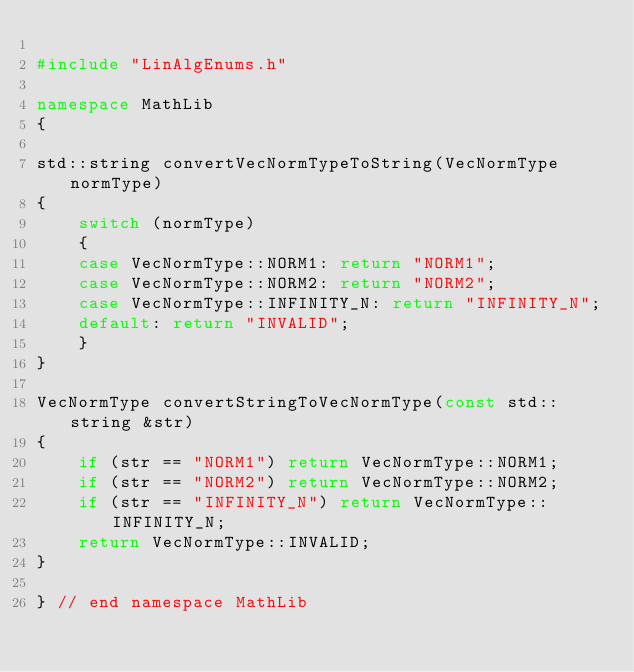Convert code to text. <code><loc_0><loc_0><loc_500><loc_500><_C++_>
#include "LinAlgEnums.h"

namespace MathLib
{

std::string convertVecNormTypeToString(VecNormType normType)
{
    switch (normType)
    {
    case VecNormType::NORM1: return "NORM1";
    case VecNormType::NORM2: return "NORM2";
    case VecNormType::INFINITY_N: return "INFINITY_N";
    default: return "INVALID";
    }
}

VecNormType convertStringToVecNormType(const std::string &str)
{
    if (str == "NORM1") return VecNormType::NORM1;
    if (str == "NORM2") return VecNormType::NORM2;
    if (str == "INFINITY_N") return VecNormType::INFINITY_N;
    return VecNormType::INVALID;
}

} // end namespace MathLib
</code> 